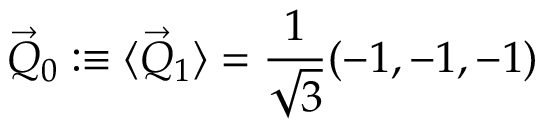<formula> <loc_0><loc_0><loc_500><loc_500>\vec { Q } _ { 0 } \colon \equiv \langle \vec { Q } _ { 1 } \rangle = \frac { 1 } { \sqrt { 3 } } ( - 1 , - 1 , - 1 )</formula> 